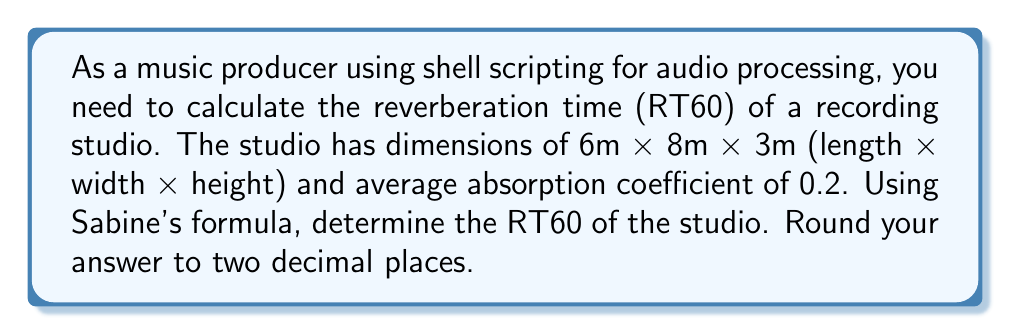Give your solution to this math problem. To solve this problem, we'll use Sabine's formula for reverberation time:

$$RT60 = \frac{0.161 \times V}{A}$$

Where:
$RT60$ is the reverberation time in seconds
$V$ is the volume of the room in cubic meters
$A$ is the total absorption in sabins

Step 1: Calculate the volume of the studio
$$V = 6m \times 8m \times 3m = 144 \text{ m}^3$$

Step 2: Calculate the surface area of the studio
$$S = 2(6 \times 8 + 6 \times 3 + 8 \times 3) = 204 \text{ m}^2$$

Step 3: Calculate the total absorption
Given the average absorption coefficient $\alpha = 0.2$
$$A = S \times \alpha = 204 \times 0.2 = 40.8 \text{ sabins}$$

Step 4: Apply Sabine's formula
$$RT60 = \frac{0.161 \times 144}{40.8} = 0.5672 \text{ seconds}$$

Step 5: Round to two decimal places
$$RT60 \approx 0.57 \text{ seconds}$$

This calculation can be easily automated using a shell script, allowing for quick estimation of reverberation times for different room configurations in your audio processing workflow.
Answer: 0.57 seconds 